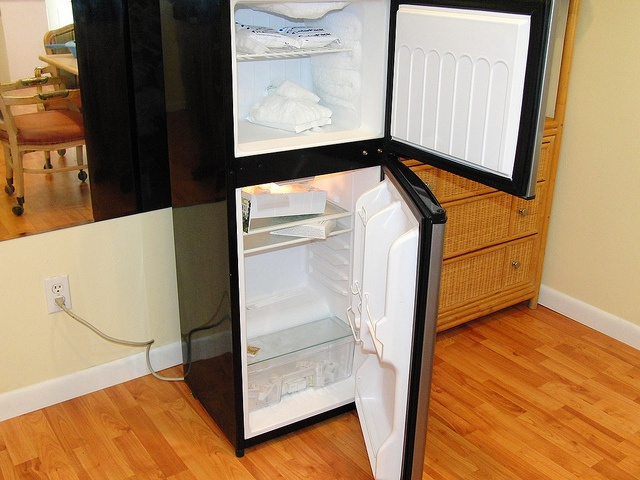Describe the objects in this image and their specific colors. I can see refrigerator in tan, lightgray, black, and darkgray tones, chair in tan, brown, and maroon tones, chair in tan, olive, and maroon tones, and dining table in tan and olive tones in this image. 